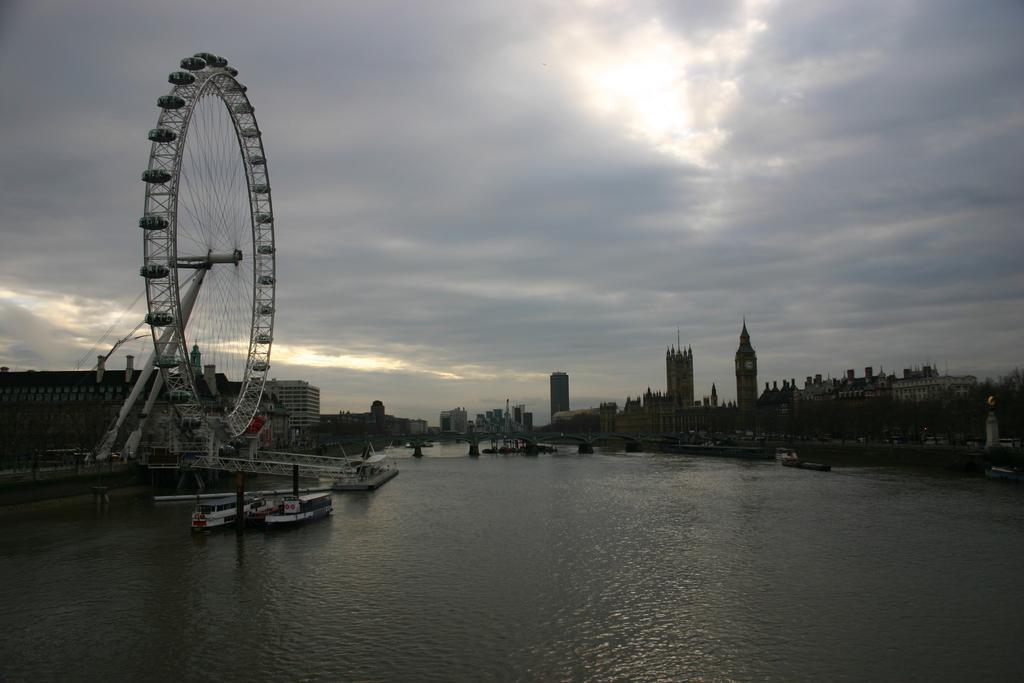Please provide a concise description of this image. In this image there is a giant wheel, buildings, water, boats, cloudy sky, railings, trees and objects. 